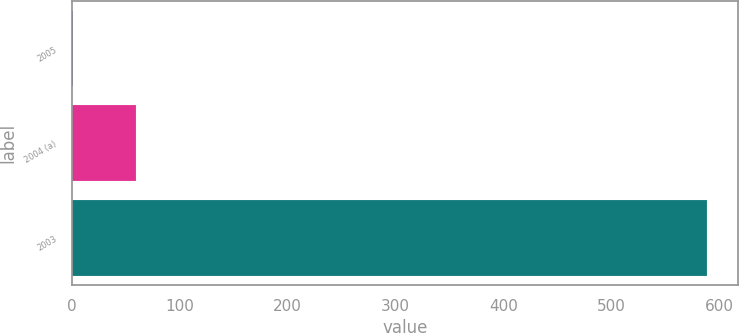Convert chart to OTSL. <chart><loc_0><loc_0><loc_500><loc_500><bar_chart><fcel>2005<fcel>2004 (a)<fcel>2003<nl><fcel>1<fcel>59.7<fcel>588<nl></chart> 